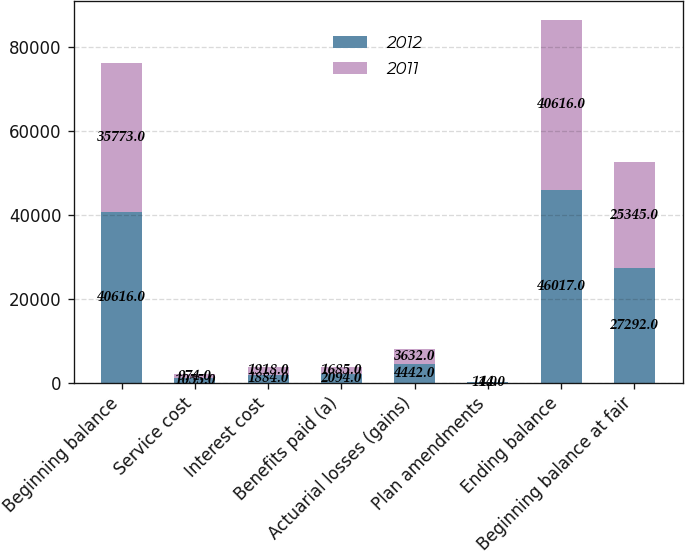Convert chart. <chart><loc_0><loc_0><loc_500><loc_500><stacked_bar_chart><ecel><fcel>Beginning balance<fcel>Service cost<fcel>Interest cost<fcel>Benefits paid (a)<fcel>Actuarial losses (gains)<fcel>Plan amendments<fcel>Ending balance<fcel>Beginning balance at fair<nl><fcel>2012<fcel>40616<fcel>1055<fcel>1884<fcel>2094<fcel>4442<fcel>114<fcel>46017<fcel>27292<nl><fcel>2011<fcel>35773<fcel>974<fcel>1918<fcel>1685<fcel>3632<fcel>4<fcel>40616<fcel>25345<nl></chart> 